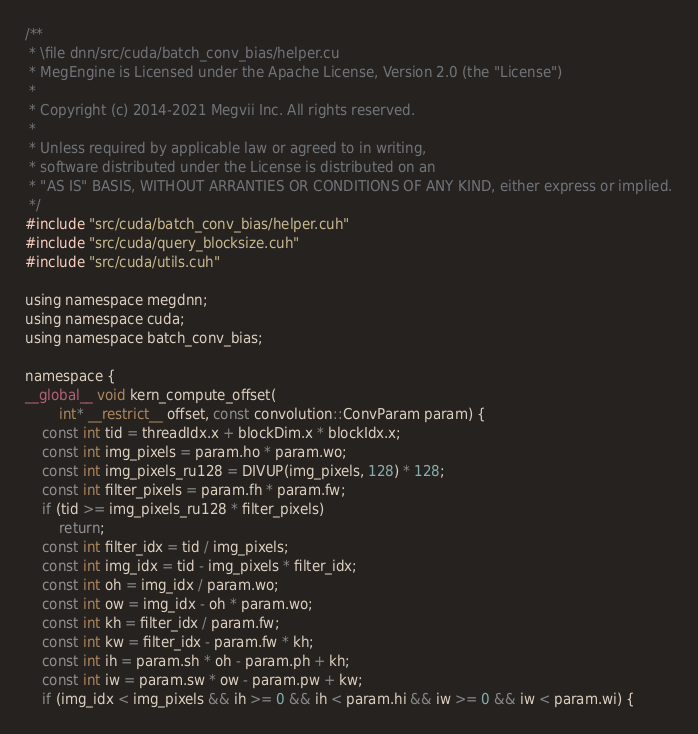Convert code to text. <code><loc_0><loc_0><loc_500><loc_500><_Cuda_>/**
 * \file dnn/src/cuda/batch_conv_bias/helper.cu
 * MegEngine is Licensed under the Apache License, Version 2.0 (the "License")
 *
 * Copyright (c) 2014-2021 Megvii Inc. All rights reserved.
 *
 * Unless required by applicable law or agreed to in writing,
 * software distributed under the License is distributed on an
 * "AS IS" BASIS, WITHOUT ARRANTIES OR CONDITIONS OF ANY KIND, either express or implied.
 */
#include "src/cuda/batch_conv_bias/helper.cuh"
#include "src/cuda/query_blocksize.cuh"
#include "src/cuda/utils.cuh"

using namespace megdnn;
using namespace cuda;
using namespace batch_conv_bias;

namespace {
__global__ void kern_compute_offset(
        int* __restrict__ offset, const convolution::ConvParam param) {
    const int tid = threadIdx.x + blockDim.x * blockIdx.x;
    const int img_pixels = param.ho * param.wo;
    const int img_pixels_ru128 = DIVUP(img_pixels, 128) * 128;
    const int filter_pixels = param.fh * param.fw;
    if (tid >= img_pixels_ru128 * filter_pixels)
        return;
    const int filter_idx = tid / img_pixels;
    const int img_idx = tid - img_pixels * filter_idx;
    const int oh = img_idx / param.wo;
    const int ow = img_idx - oh * param.wo;
    const int kh = filter_idx / param.fw;
    const int kw = filter_idx - param.fw * kh;
    const int ih = param.sh * oh - param.ph + kh;
    const int iw = param.sw * ow - param.pw + kw;
    if (img_idx < img_pixels && ih >= 0 && ih < param.hi && iw >= 0 && iw < param.wi) {</code> 